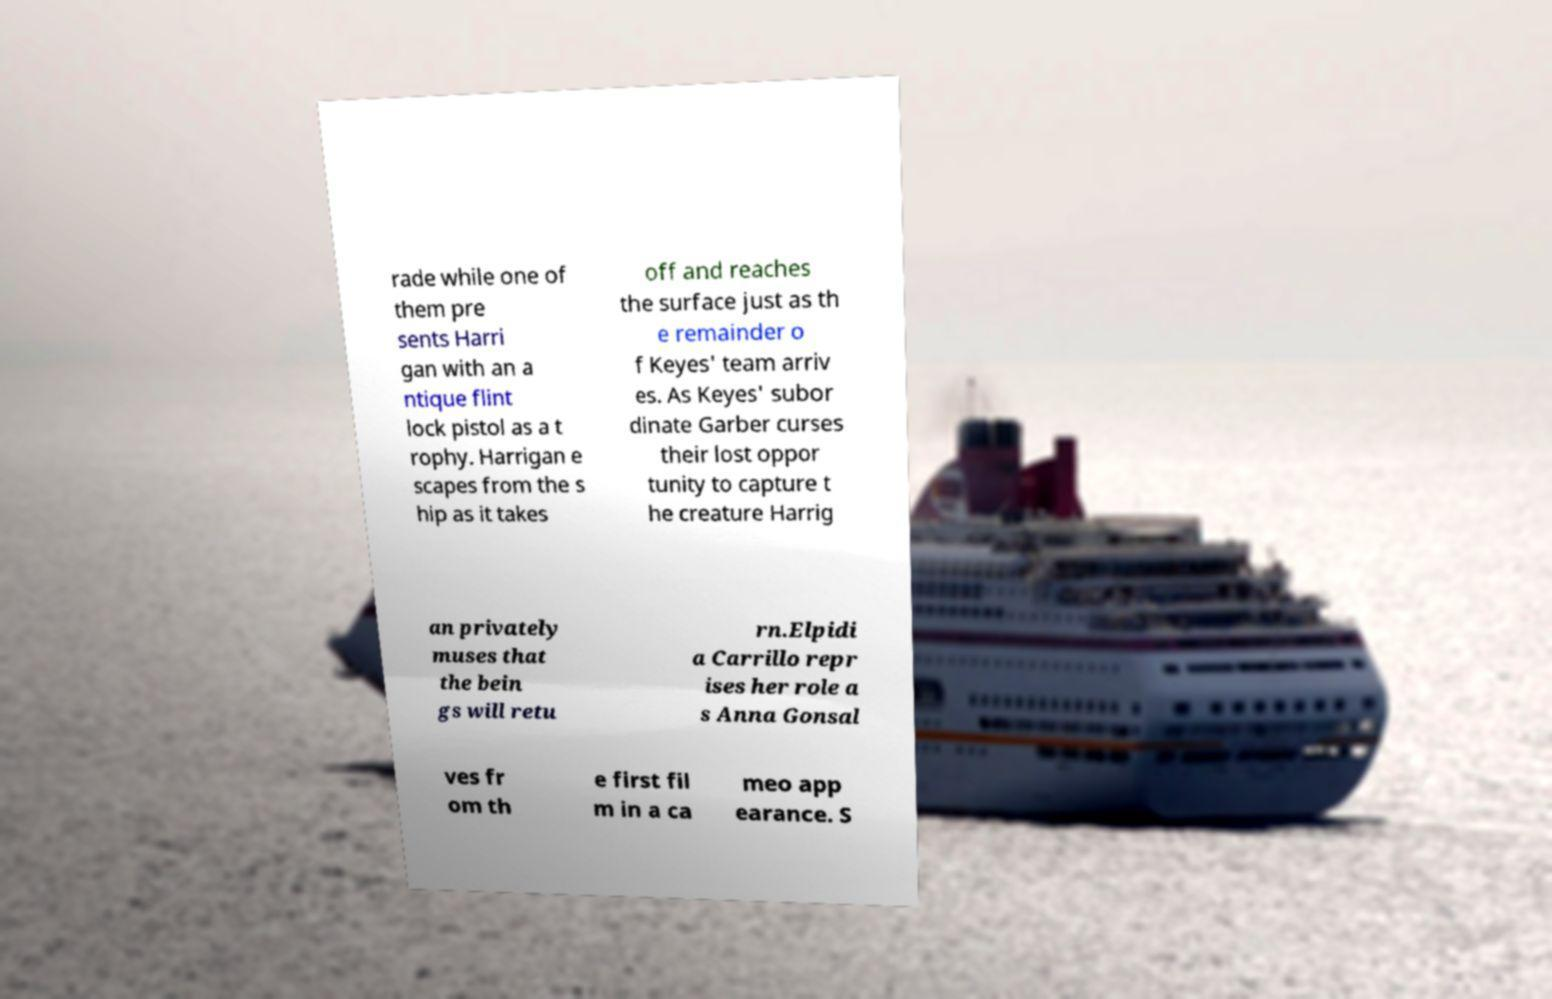Can you accurately transcribe the text from the provided image for me? rade while one of them pre sents Harri gan with an a ntique flint lock pistol as a t rophy. Harrigan e scapes from the s hip as it takes off and reaches the surface just as th e remainder o f Keyes' team arriv es. As Keyes' subor dinate Garber curses their lost oppor tunity to capture t he creature Harrig an privately muses that the bein gs will retu rn.Elpidi a Carrillo repr ises her role a s Anna Gonsal ves fr om th e first fil m in a ca meo app earance. S 